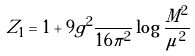Convert formula to latex. <formula><loc_0><loc_0><loc_500><loc_500>Z _ { 1 } = 1 + 9 g ^ { 2 } \frac { } { 1 6 \pi ^ { 2 } } \log \frac { M ^ { 2 } } { \mu ^ { 2 } }</formula> 